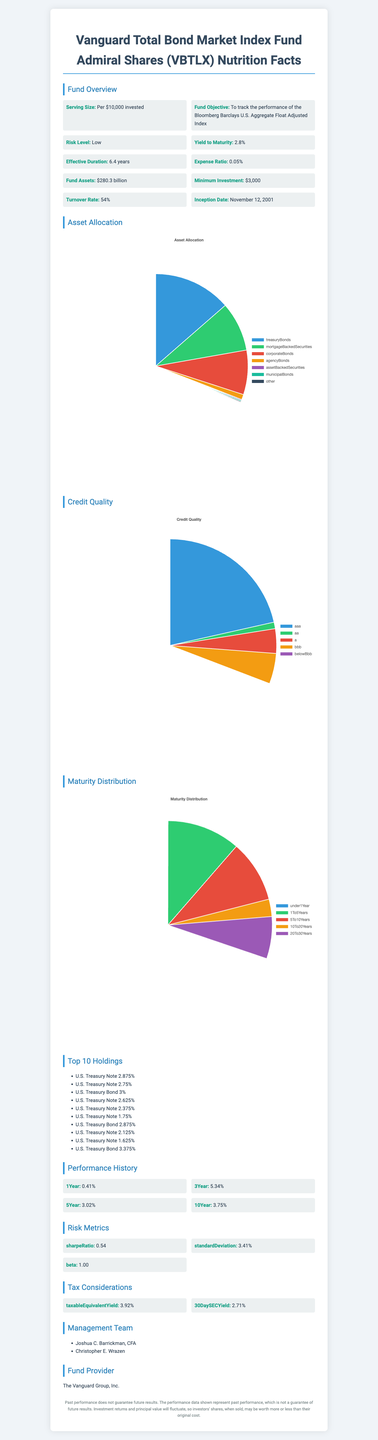what is the serving size for VBTLX? The document specifies the serving size as "Per $10,000 invested".
Answer: Per $10,000 invested who are the fund managers? The document lists the fund management team as Joshua C. Barrickman, CFA, and Christopher E. Wrazen.
Answer: Joshua C. Barrickman, CFA and Christopher E. Wrazen what percentage of the fund is allocated to mortgage-backed securities? The document states that 27.5% of the fund is allocated to mortgage-backed securities.
Answer: 27.5% what is the expense ratio for the fund? The document mentions that the expense ratio of the fund is 0.05%.
Answer: 0.05% how long is the fund's effective duration? The effective duration of the fund, as indicated in the document, is 6.4 years.
Answer: 6.4 years what is the risk level of the fund? The document specifies that the fund has a low risk level.
Answer: Low what is the inception date of Vanguard Total Bond Market Index Fund Admiral Shares (VBTLX)? The document states the inception date as November 12, 2001.
Answer: November 12, 2001 what is the fund's yield to maturity? The yield to maturity of the fund, according to the document, is 2.8%.
Answer: 2.8% how is the fund's asset allocation distributed? The document lists the detailed asset allocation as Treasury Bonds: 43.2%, Mortgage-Backed Securities: 27.5%, Corporate Bonds: 24.8%, Agency Bonds: 2.9%, Asset-Backed Securities: 0.5%, Municipal Bonds: 0.6%, Other: 0.5%.
Answer: Treasury Bonds: 43.2%, Mortgage-Backed Securities: 27.5%, Corporate Bonds: 24.8%, Agency Bonds: 2.9%, Asset-Backed Securities: 0.5%, Municipal Bonds: 0.6%, Other: 0.5% how many holdings are in the top ten list? The document shows a list of the top ten holdings, indicating there are 10 holdings.
Answer: 10 what is the percentage of fund assets rated AAA? The document indicates that 69.7% of the fund assets are rated AAA.
Answer: 69.7% what is the standard deviation of the fund? The standard deviation of the fund, as provided in the document, is 3.41%.
Answer: 3.41% what is the fund's 10-year performance return? The document lists the 10-year performance return as 3.75%.
Answer: 3.75% for how many years should the fund be held to get the highest percentage of maturity distribution? The document shows the highest percentage of maturity distribution (37.6%) in the 1 to 5 years category.
Answer: 1 to 5 Years what is the fund's minimum investment amount? The minimum investment required for the fund, as mentioned in the document, is $3,000.
Answer: $3,000 what is the taxable equivalent yield of the fund? The document specifies a taxable equivalent yield of 3.92%.
Answer: 3.92% which holding has the highest interest rate among the top 10 holdings? Among the top 10 holdings, both U.S. Treasury Bond 3% and U.S. Treasury Bond 3.375% have higher interest rates compared to the others listed.
Answer: U.S. Treasury Bond 3% and U.S. Treasury Bond 3.375% to which index does the fund aim to track its performance? A. S&P 500 B. Bloomberg Barclays U.S. Aggregate Bond Index C. Russell 2000 D. Bloomberg Barclays U.S. Aggregate Float Adjusted Index E. NASDAQ The document mentions that the fund's objective is to track the performance of the Bloomberg Barclays U.S. Aggregate Float Adjusted Index.
Answer: D what is the fund's performance history over the past 1 year? A. 3.75% B. 0.41% C. 5.34% According to the document, the fund's 1-year performance history is 0.41%.
Answer: B is the fund suitable for investors seeking high-risk investments? The document clearly states that the risk level of the fund is low, implying that it is not suitable for investors seeking high-risk investments.
Answer: No summarize the key characteristics and performance of the Vanguard Total Bond Market Index Fund Admiral Shares (VBTLX). This summary explains the main features and performance metrics of the VBTLX fund as documented, including its asset allocation, risk level, duration, returns, and management.
Answer: The Vanguard Total Bond Market Index Fund Admiral Shares (VBTLX) aims to track the Bloomberg Barclays U.S. Aggregate Float Adjusted Index, offering a low-risk investment primarily in treasury bonds (43.2%), mortgage-backed securities (27.5%), and corporate bonds (24.8%). The fund has an inception date of November 12, 2001, an effective duration of 6.4 years, a yield to maturity of 2.8%, and an expense ratio of 0.05%. The performance history shows steady returns over different periods: 1 year (0.41%), 3 years (5.34%), 5 years (3.02%), and 10 years (3.75%). With 69.7% of its assets rated AAA, the fund emphasizes credit quality. The management team comprises Joshua C. Barrickman, CFA, and Christopher E. Wrazen, and the minimum investment required is $3,000. how does the fund's turnover rate compare to industry averages? The document does not provide information on industry averages for turnover rates, making it impossible to compare the fund's turnover rate accurately.
Answer: Not enough information 